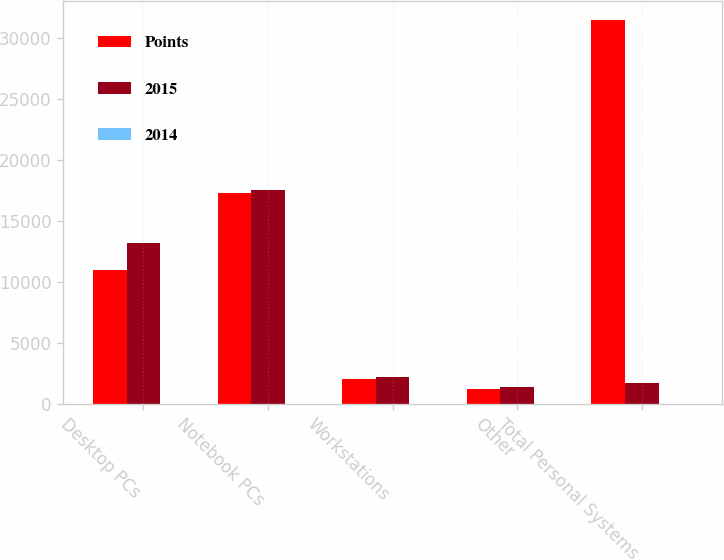<chart> <loc_0><loc_0><loc_500><loc_500><stacked_bar_chart><ecel><fcel>Desktop PCs<fcel>Notebook PCs<fcel>Workstations<fcel>Other<fcel>Total Personal Systems<nl><fcel>Points<fcel>10941<fcel>17271<fcel>2018<fcel>1239<fcel>31469<nl><fcel>2015<fcel>13197<fcel>17540<fcel>2218<fcel>1348<fcel>1683<nl><fcel>2014<fcel>6.6<fcel>0.8<fcel>0.6<fcel>0.3<fcel>8.3<nl></chart> 